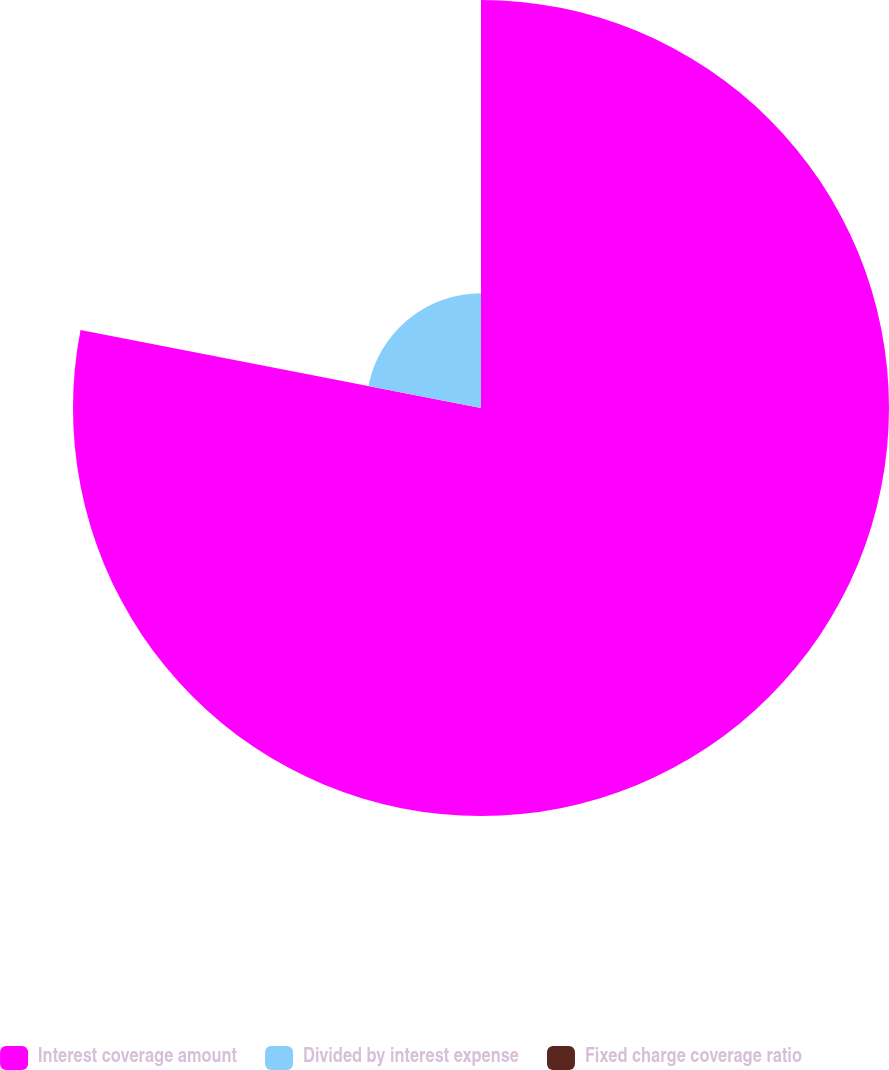Convert chart to OTSL. <chart><loc_0><loc_0><loc_500><loc_500><pie_chart><fcel>Interest coverage amount<fcel>Divided by interest expense<fcel>Fixed charge coverage ratio<nl><fcel>78.06%<fcel>21.94%<fcel>0.0%<nl></chart> 